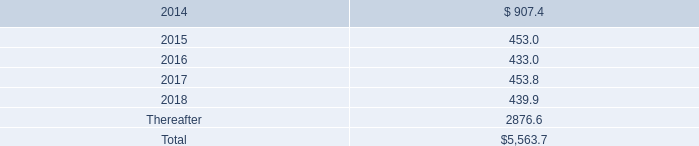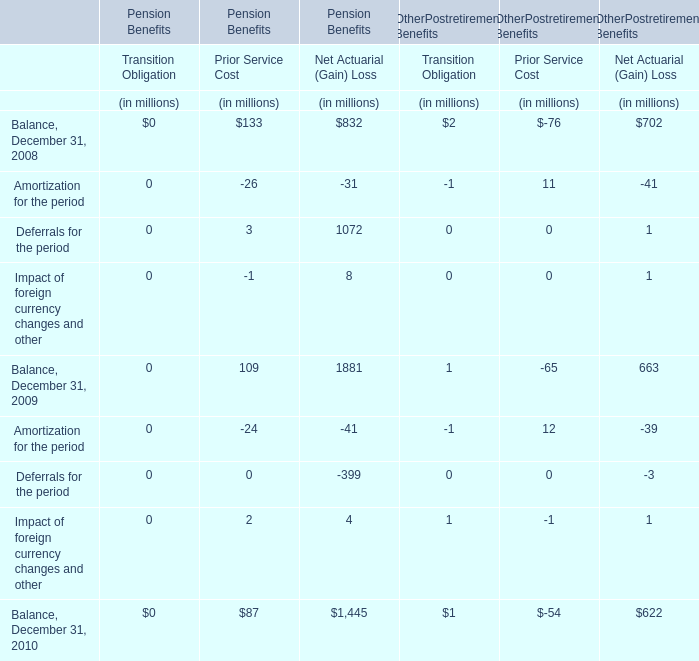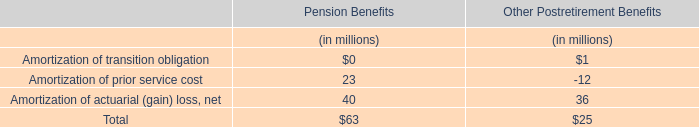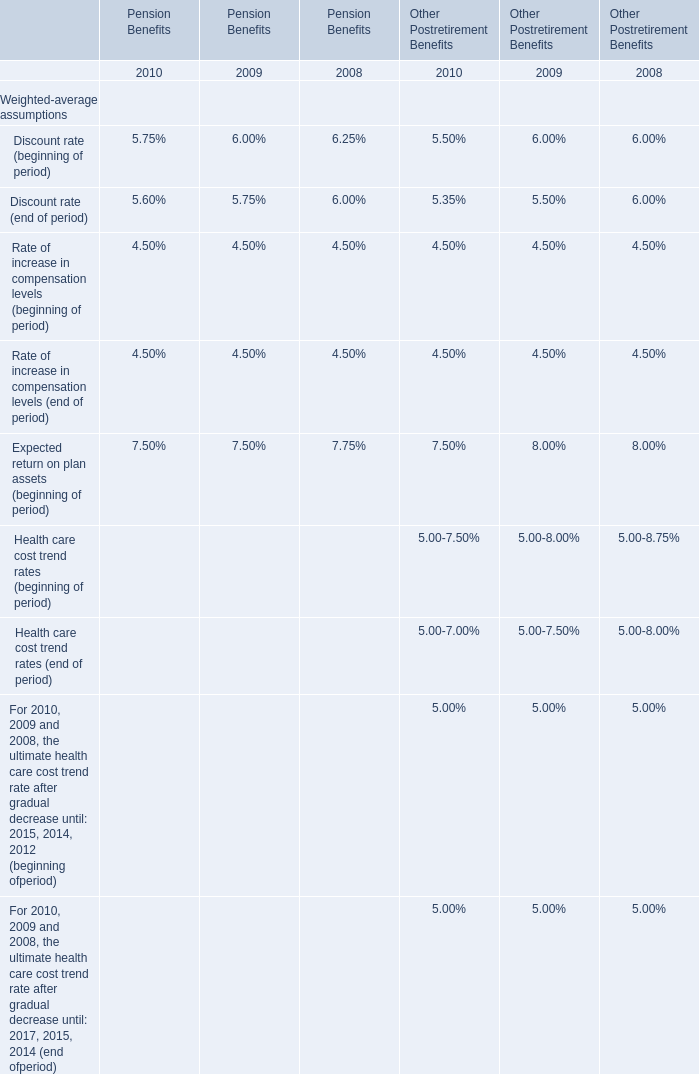what is going to be the matured value of the eurobond issued in 2013 , in millions? 
Computations: (397 * exp((1 + 2.0%))
Answer: 456.02821. 